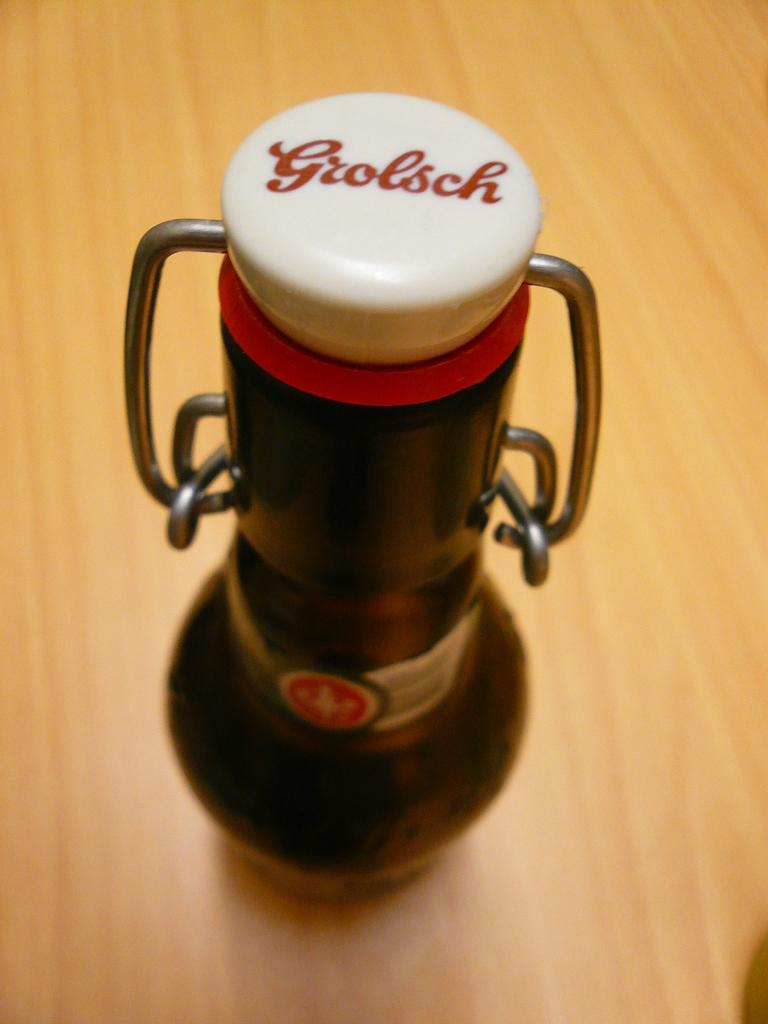<image>
Give a short and clear explanation of the subsequent image. A Grolsch device is displayed on wooden surface. 